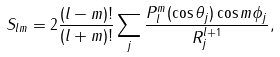Convert formula to latex. <formula><loc_0><loc_0><loc_500><loc_500>S _ { l m } = 2 \frac { ( l - m ) ! } { ( l + m ) ! } \sum _ { j } \frac { P _ { l } ^ { m } ( \cos \theta _ { j } ) \cos m \phi _ { j } } { R _ { j } ^ { l + 1 } } ,</formula> 